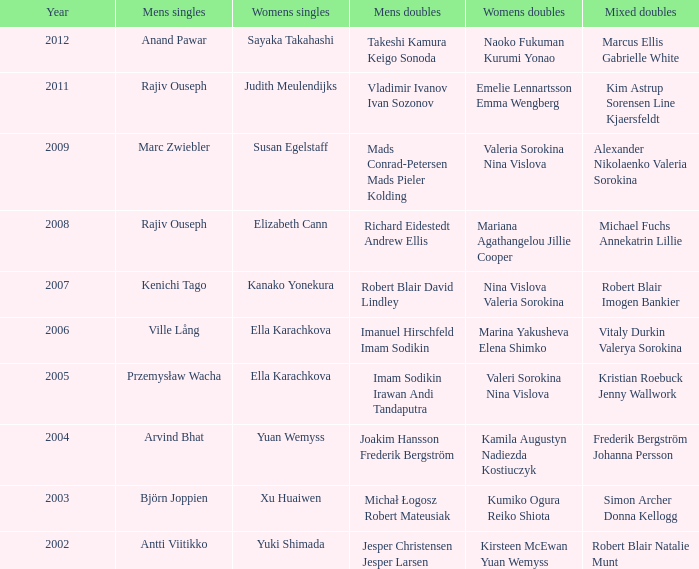What are the womens singles of naoko fukuman kurumi yonao? Sayaka Takahashi. 